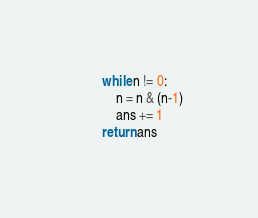<code> <loc_0><loc_0><loc_500><loc_500><_Python_>        while n != 0:
            n = n & (n-1)
            ans += 1
        return ans</code> 